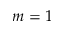<formula> <loc_0><loc_0><loc_500><loc_500>m = 1</formula> 